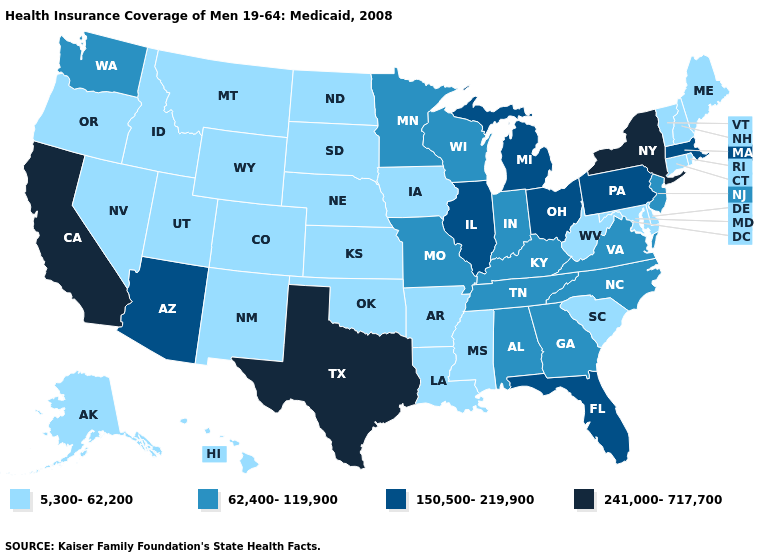Does Maryland have the highest value in the USA?
Quick response, please. No. What is the value of Hawaii?
Short answer required. 5,300-62,200. What is the lowest value in the West?
Concise answer only. 5,300-62,200. How many symbols are there in the legend?
Concise answer only. 4. Does Arizona have the highest value in the USA?
Short answer required. No. Does Delaware have the same value as Tennessee?
Answer briefly. No. How many symbols are there in the legend?
Give a very brief answer. 4. What is the value of California?
Give a very brief answer. 241,000-717,700. Among the states that border Idaho , does Washington have the highest value?
Write a very short answer. Yes. Which states hav the highest value in the West?
Short answer required. California. Name the states that have a value in the range 5,300-62,200?
Quick response, please. Alaska, Arkansas, Colorado, Connecticut, Delaware, Hawaii, Idaho, Iowa, Kansas, Louisiana, Maine, Maryland, Mississippi, Montana, Nebraska, Nevada, New Hampshire, New Mexico, North Dakota, Oklahoma, Oregon, Rhode Island, South Carolina, South Dakota, Utah, Vermont, West Virginia, Wyoming. Does Nebraska have the highest value in the MidWest?
Concise answer only. No. Which states have the lowest value in the USA?
Answer briefly. Alaska, Arkansas, Colorado, Connecticut, Delaware, Hawaii, Idaho, Iowa, Kansas, Louisiana, Maine, Maryland, Mississippi, Montana, Nebraska, Nevada, New Hampshire, New Mexico, North Dakota, Oklahoma, Oregon, Rhode Island, South Carolina, South Dakota, Utah, Vermont, West Virginia, Wyoming. What is the highest value in states that border North Dakota?
Give a very brief answer. 62,400-119,900. Does the first symbol in the legend represent the smallest category?
Be succinct. Yes. 